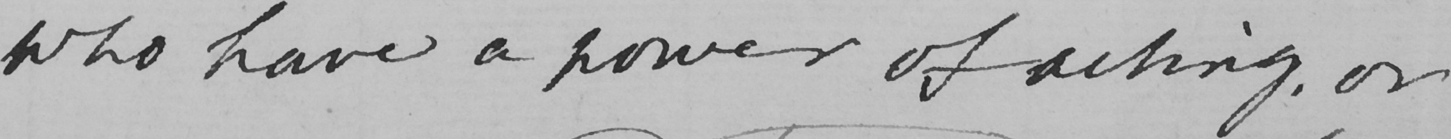What does this handwritten line say? who have a power of asking or 